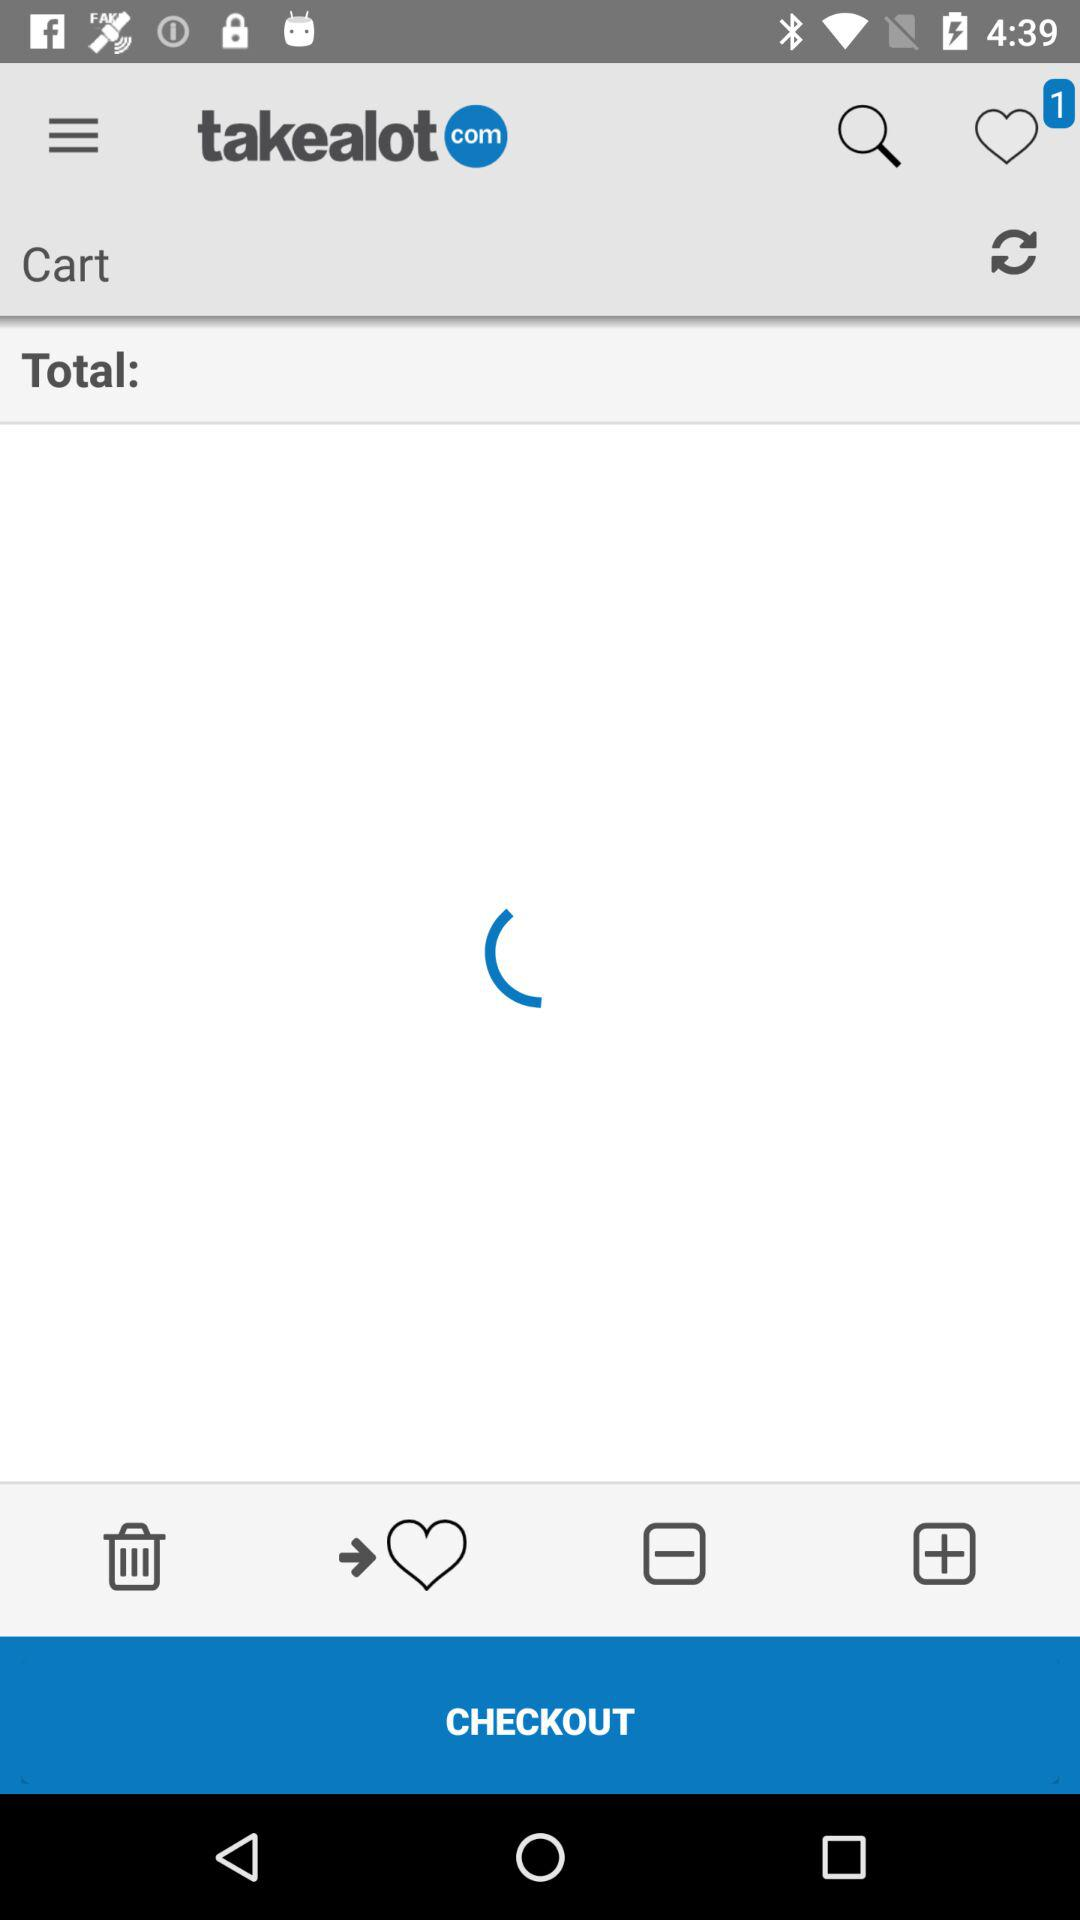How many unread message?
When the provided information is insufficient, respond with <no answer>. <no answer> 